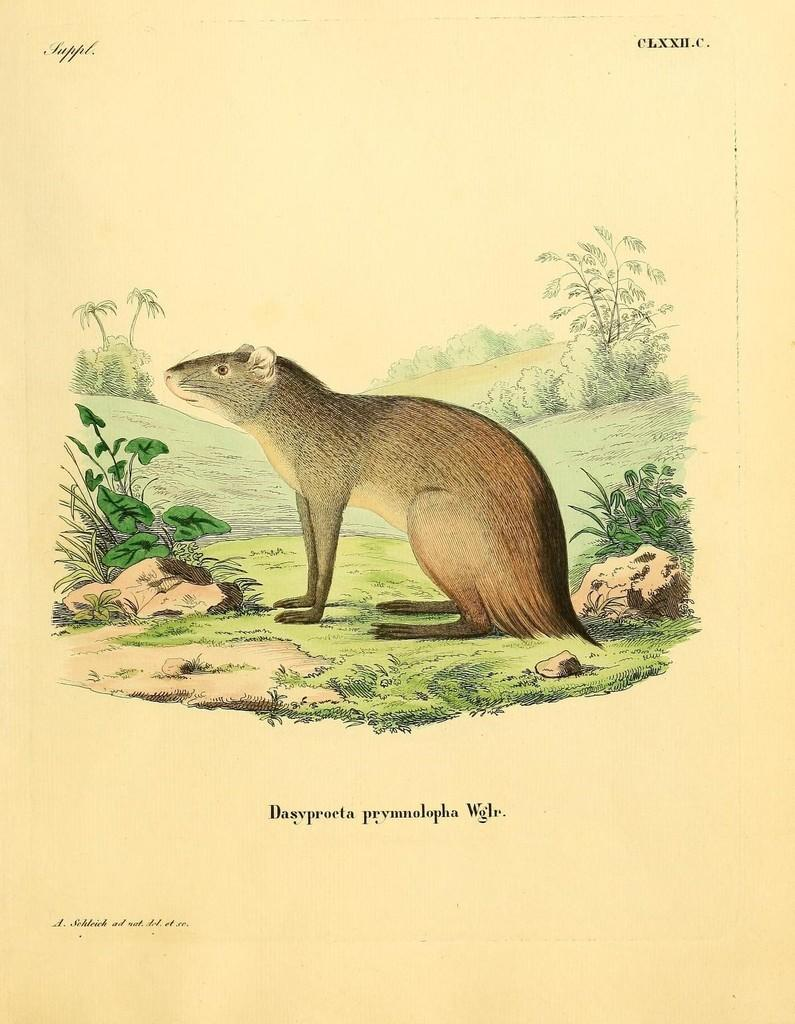What type of animal is in the picture? There is an animal in the picture, but the specific type cannot be determined from the facts provided. What is on the floor in the picture? There is grass on the floor in the picture. What other elements can be seen in the picture? There are rocks in the picture. How was the image created? The image is a drawing. What can be found at the bottom of the image? There is something written at the bottom of the image. How many jellyfish are swimming in the grass in the picture? There are no jellyfish present in the picture; it features an animal, grass, and rocks. What type of box is used to store the animal in the picture? There is no box present in the picture, and the animal is not being stored. 